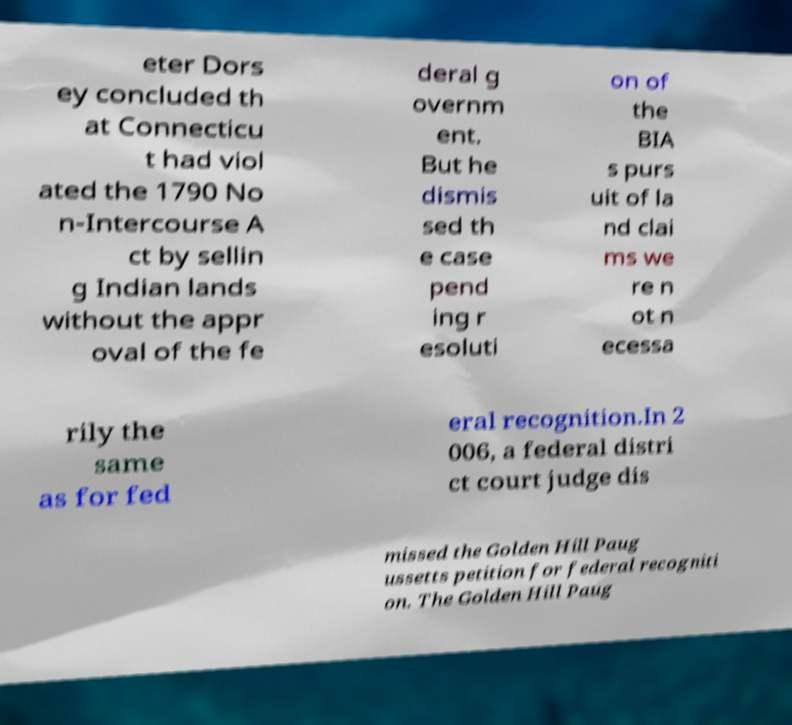What messages or text are displayed in this image? I need them in a readable, typed format. eter Dors ey concluded th at Connecticu t had viol ated the 1790 No n-Intercourse A ct by sellin g Indian lands without the appr oval of the fe deral g overnm ent. But he dismis sed th e case pend ing r esoluti on of the BIA s purs uit of la nd clai ms we re n ot n ecessa rily the same as for fed eral recognition.In 2 006, a federal distri ct court judge dis missed the Golden Hill Paug ussetts petition for federal recogniti on. The Golden Hill Paug 